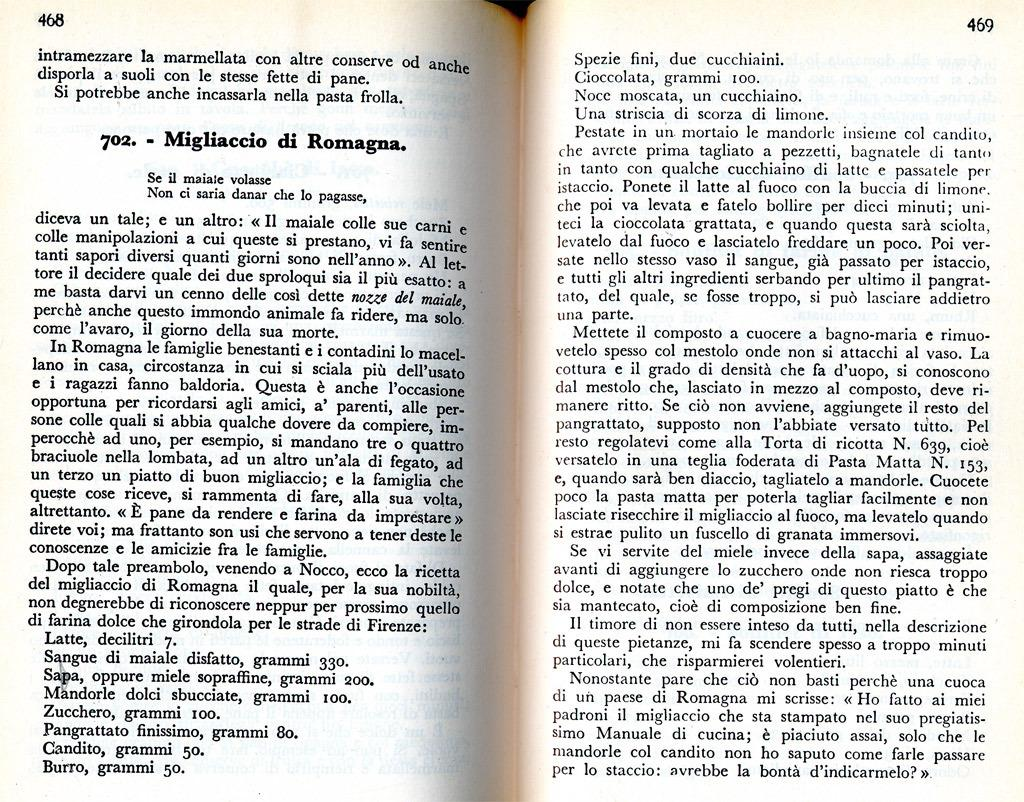<image>
Write a terse but informative summary of the picture. An open book on page 468 with a heading 702. Migliaccio di Romagna. 